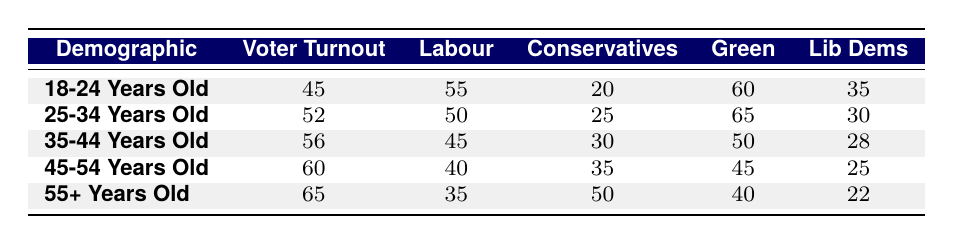What is the voter turnout rate for the 18-24 age group? The voter turnout rate for the 18-24 age group is listed directly in the table under the 'Voter Turnout' column for that demographic. It shows as 45.
Answer: 45 Which demographic has the highest approval rating for the Labour party? By scanning the table, we see that the demographic of 18-24 years old has the highest approval rating for the Labour party at 55.
Answer: 18-24 Years Old What is the difference in approval ratings for Conservatives between the 25-34 age group and the 45-54 age group? Looking at the table, the approval rating for Conservatives in the 25-34 age group is 25, while for the 45-54 age group it is 35. The difference is 35 - 25 = 10.
Answer: 10 Is the approval rating for the Green party higher among those aged 25-34 or 35-44? For the 25-34 age group, the approval rating for the Green party is 65, while for the 35-44 age group it is 50. Since 65 is greater than 50, the answer is yes, it is higher in the 25-34 age group.
Answer: Yes What are the average approval ratings for the Liberal Democrats across all demographics? To find the average, add all Liberal Democrat approval ratings (35 + 30 + 28 + 25 + 22 = 140) and divide by the number of demographics (5). The average is 140 / 5 = 28.
Answer: 28 Which age group shows a decline in approval rating for Labour as compared to the previous group? By observing the Labour approval ratings: 55 (18-24) to 50 (25-34) to 45 (35-44), we can see that the approval rating declined from 55 to 50 for the 18-24 to 25-34 age groups, and again from 50 to 45 for 25-34 to 35-44. Therefore, both transitions show a decline.
Answer: 18-24 to 25-34 and 25-34 to 35-44 Do older voters (55+ years) generally show stronger support for Conservative or Labour? In the 55+ demographic, the approval rating for Conservatives is 50, while for Labour it is 35. Since 50 is greater than 35, this means older voters show stronger support for the Conservatives.
Answer: Conservatives What is the voter turnout trend as the age of the demographic increases? By examining the voter turnout rates, we see they increase from 45 for 18-24 to 65 for 55+, indicating a trend of rising voter turnout with increasing age.
Answer: Rising 